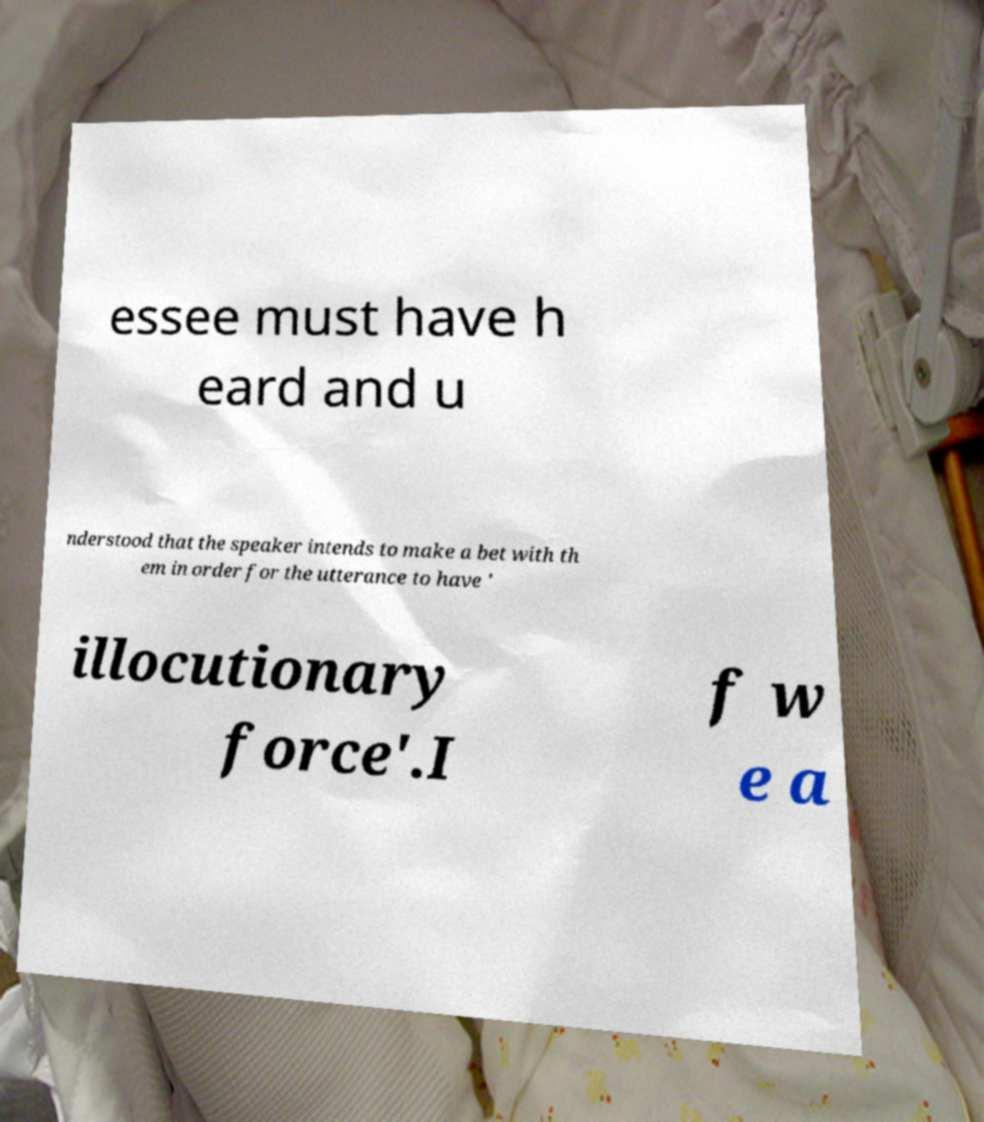Can you accurately transcribe the text from the provided image for me? essee must have h eard and u nderstood that the speaker intends to make a bet with th em in order for the utterance to have ' illocutionary force'.I f w e a 